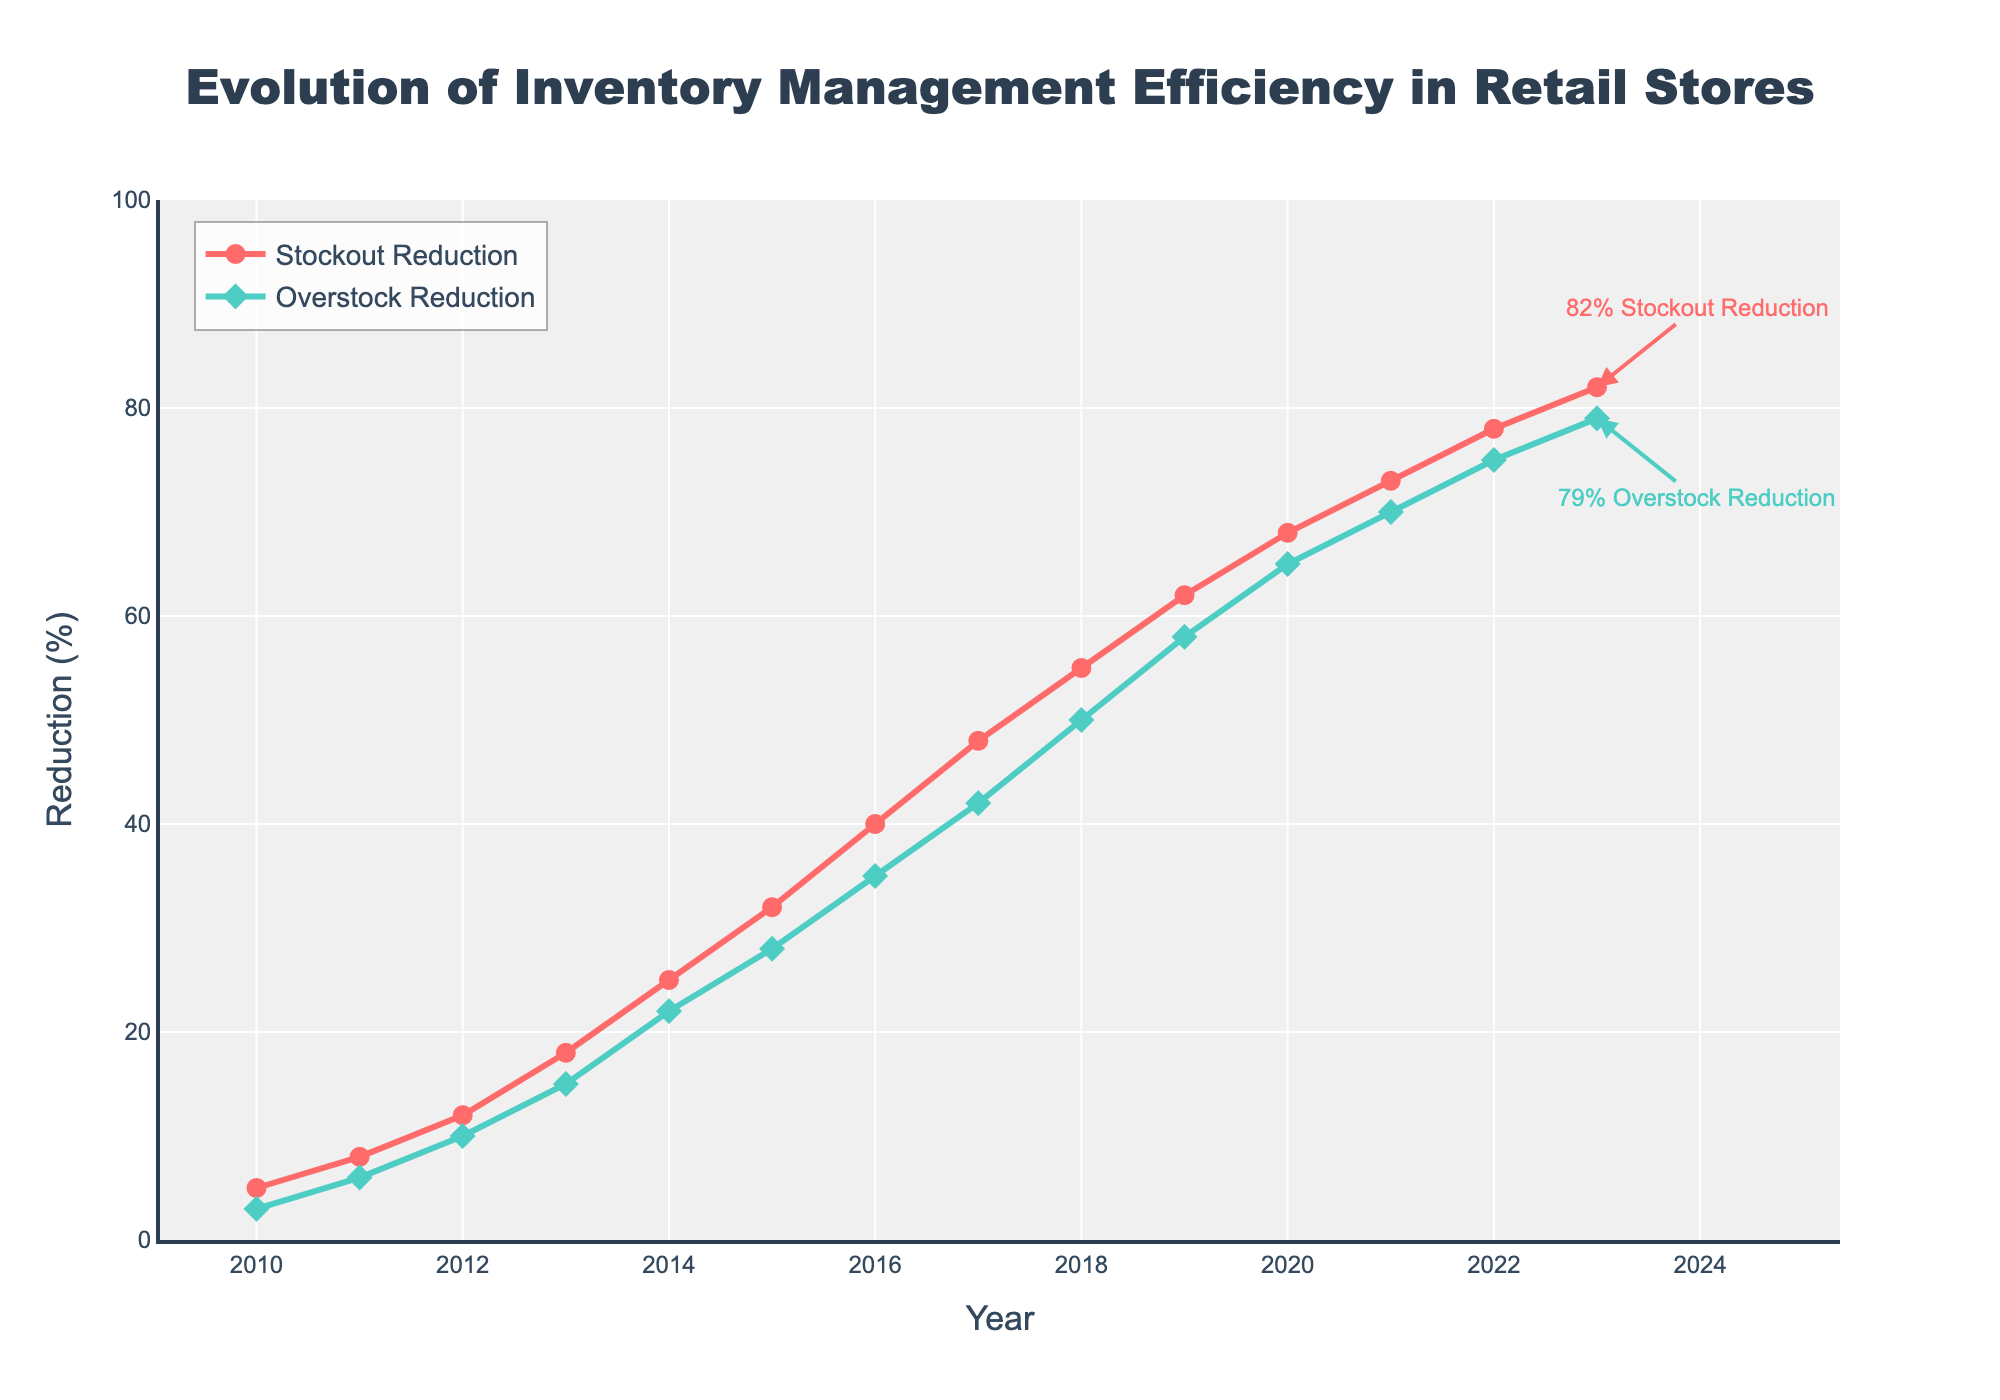What is the percentage reduction in stockouts in 2020? To find the percentage reduction in stockouts in 2020, look at the Stockout Reduction line on the chart and locate the value for the year 2020. The annotation shows that in 2020 the Stockout Reduction was 68%.
Answer: 68% How much higher was the overstock reduction in 2023 compared to 2010? First, find the Overstock Reduction values for 2010 and 2023 from the graph. In 2010, it was 3%, and in 2023, it was 79%. Subtract the 2010 value from the 2023 value: 79% - 3% = 76%.
Answer: 76% During which year did the stockout reduction percentage first exceed 50%? Follow the Stockout Reduction line and observe the year labels to find the first year when the value exceeds 50%. The values are below 50% up until 2017, where it reaches 48%, and it exceeds 50% in 2018 reaching 55%.
Answer: 2018 What is the average percentage reduction in stockouts from 2010 to 2013? Sum the Stockout Reduction values from 2010 to 2013: 5% + 8% + 12% + 18% = 43%. Divide this sum by the number of years, which is 4. Therefore, the average reduction is 43% / 4 = 10.75%.
Answer: 10.75% Compare the trend in stockout and overstock reduction between 2015 and 2020. Which one shows a steeper increase? Examine the increase in both Stockout Reduction and Overstock Reduction values from 2015 to 2020. Stockout Reduction increases from 32% to 68%, a difference of 36%. Overstock Reduction increases from 28% to 65%, a difference of 37%. The trend lines show that Overstock Reduction had a slightly steeper increase in this period.
Answer: Overstock Reduction What is the difference between stockout reduction and overstock reduction in 2021? Look at the chart to find the Stockout Reduction and Overstock Reduction values for 2021. Stockout Reduction is 73%, and Overstock Reduction is 70%. Calculate the difference: 73% - 70% = 3%.
Answer: 3% What was the stockout reduction rate in 2015 compared to 2012? Find the Stockout Reduction values for both years: 2012 is 12%, and 2015 is 32%. Calculate the ratio: 32% / 12% ≈ 2.67. Thus, the reduction rate in 2015 was approximately 2.67 times higher than in 2012.
Answer: 2.67 times Which aspect, stockout or overstock, had a greater reduction percentage in 2018? Examine the reduction percentages for stockouts and overstocks for the year 2018. Stockout Reduction is 55%, and Overstock Reduction is 50%. Stockout Reduction had a greater reduction percentage.
Answer: Stockout How many years did it take for stockout reduction to increase from 5% to above 70%? Identify the years when Stockout Reduction was 5% and first exceeded 70%. From the chart, 5% is in 2010, and it exceeds 70% in 2021. The number of years taken is 2021 - 2010 = 11 years.
Answer: 11 years Which year experienced the most significant annual increase in stockout reduction rate? Analyze the increments in Stockout Reduction between consecutive years. The most significant increase is seen from 2017 (48%) to 2018 (55%), which is an increase of 7%.
Answer: 2018 